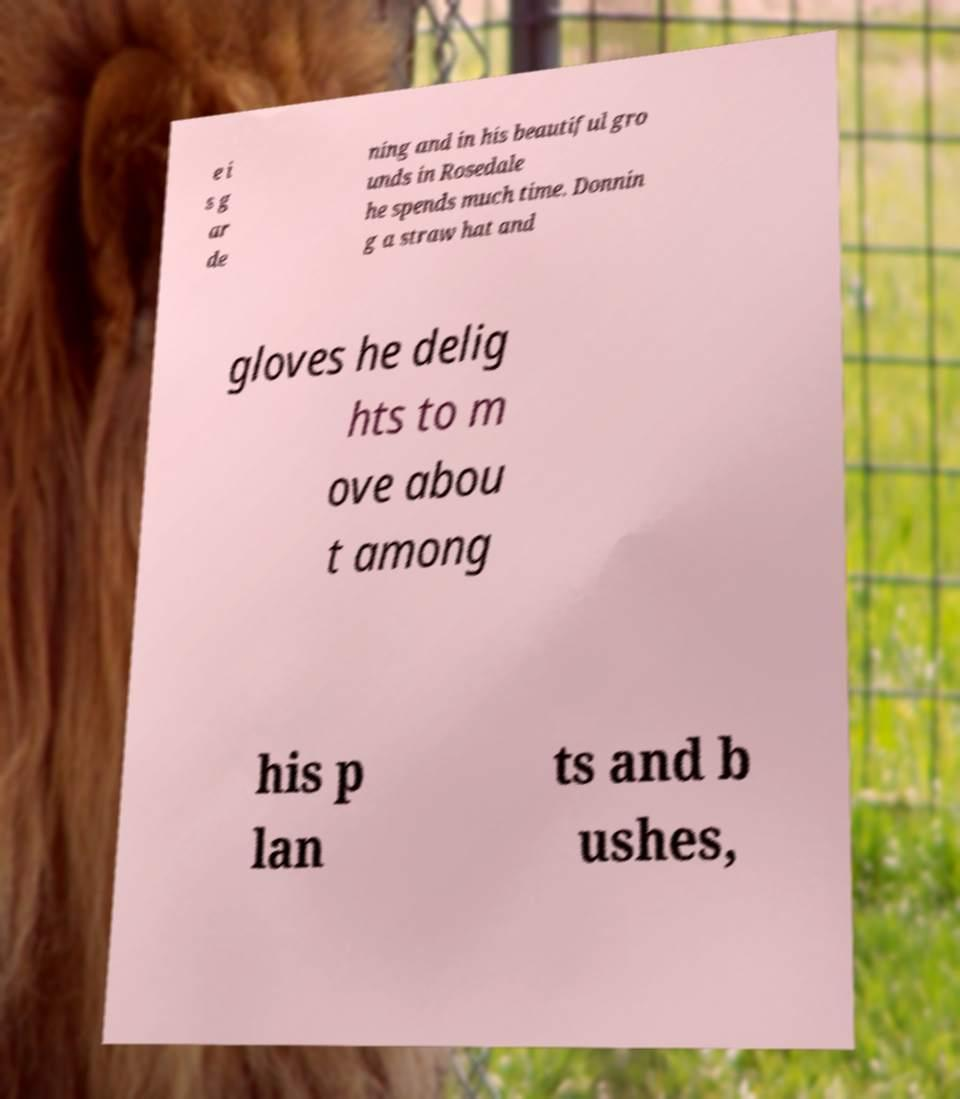Can you read and provide the text displayed in the image?This photo seems to have some interesting text. Can you extract and type it out for me? e i s g ar de ning and in his beautiful gro unds in Rosedale he spends much time. Donnin g a straw hat and gloves he delig hts to m ove abou t among his p lan ts and b ushes, 